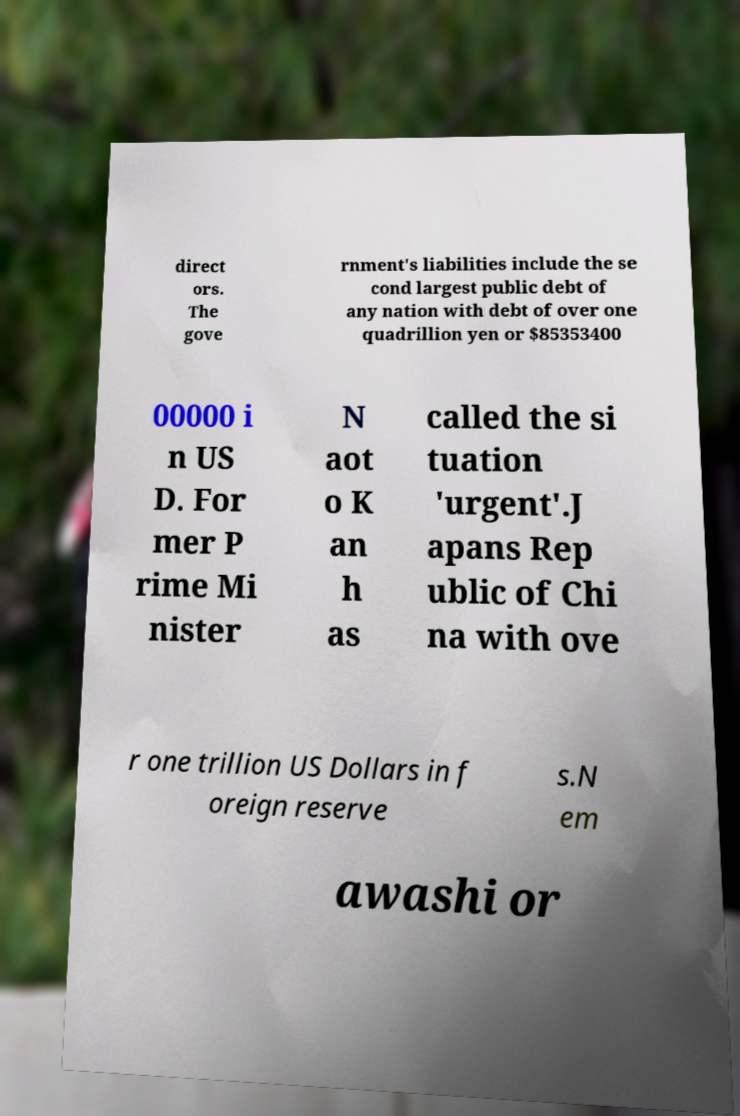Could you assist in decoding the text presented in this image and type it out clearly? direct ors. The gove rnment's liabilities include the se cond largest public debt of any nation with debt of over one quadrillion yen or $85353400 00000 i n US D. For mer P rime Mi nister N aot o K an h as called the si tuation 'urgent'.J apans Rep ublic of Chi na with ove r one trillion US Dollars in f oreign reserve s.N em awashi or 